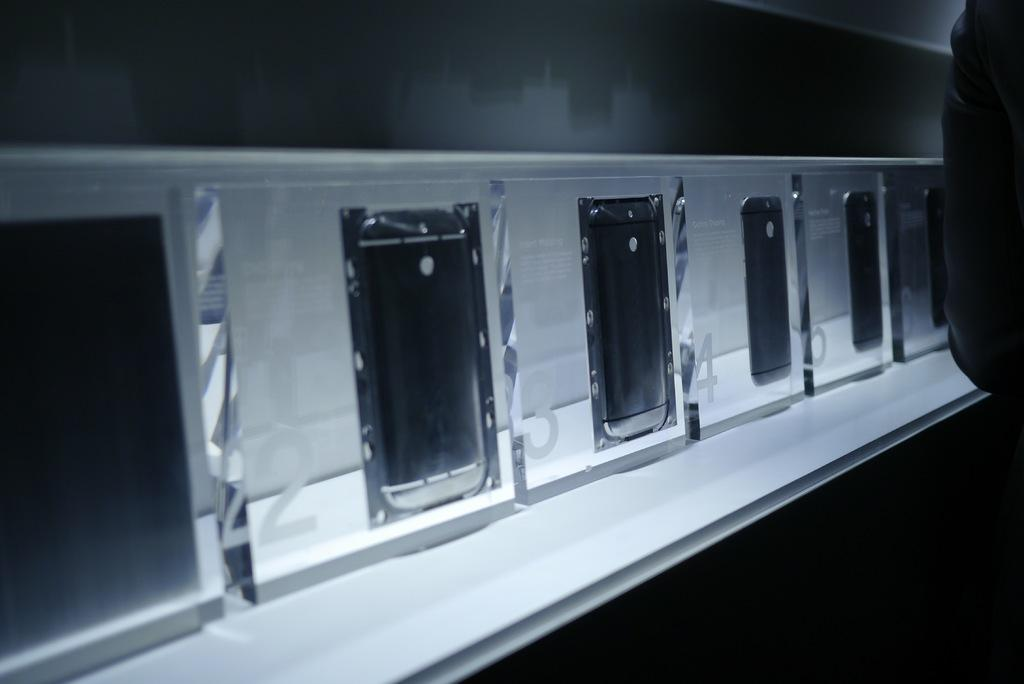<image>
Offer a succinct explanation of the picture presented. Phones displayed in a clear case are numbered 2, 3, and 4. 